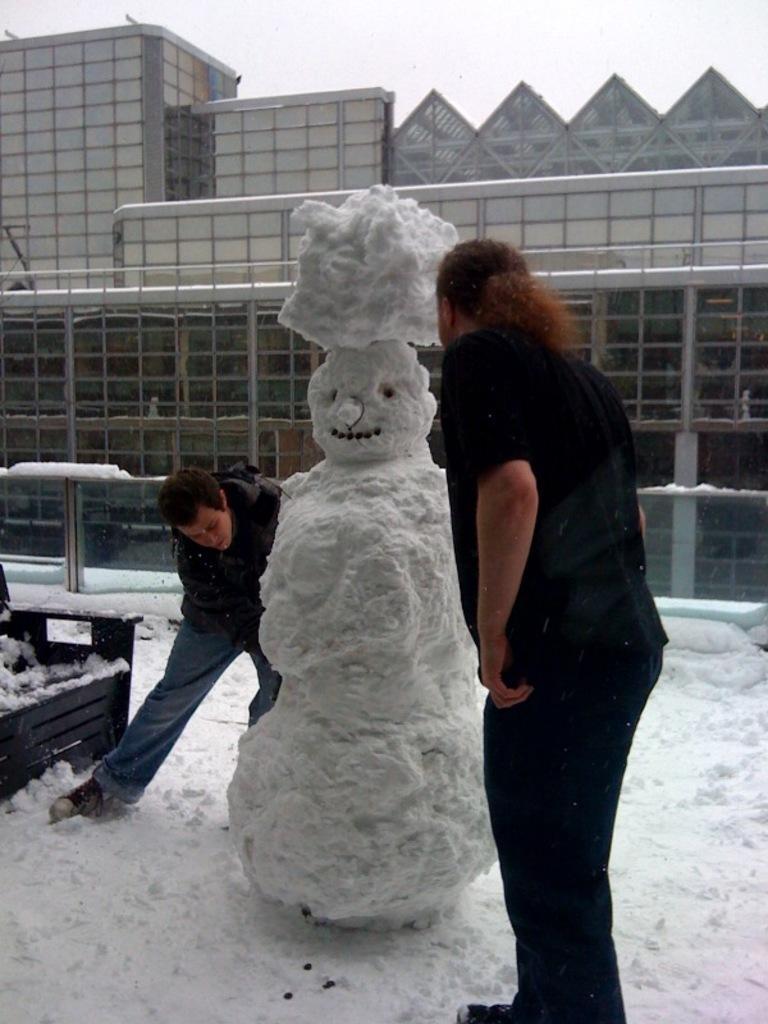Could you give a brief overview of what you see in this image? In this image there are two people standing on the surface of the snow, in the middle of them there is a snowman. On the left side of the image there is an object. In the background there is a building and the sky. 